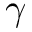<formula> <loc_0><loc_0><loc_500><loc_500>\gamma</formula> 